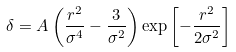Convert formula to latex. <formula><loc_0><loc_0><loc_500><loc_500>\delta = A \left ( \frac { r ^ { 2 } } { \sigma ^ { 4 } } - \frac { 3 } { \sigma ^ { 2 } } \right ) \exp \left [ - \frac { r ^ { 2 } } { 2 \sigma ^ { 2 } } \right ]</formula> 